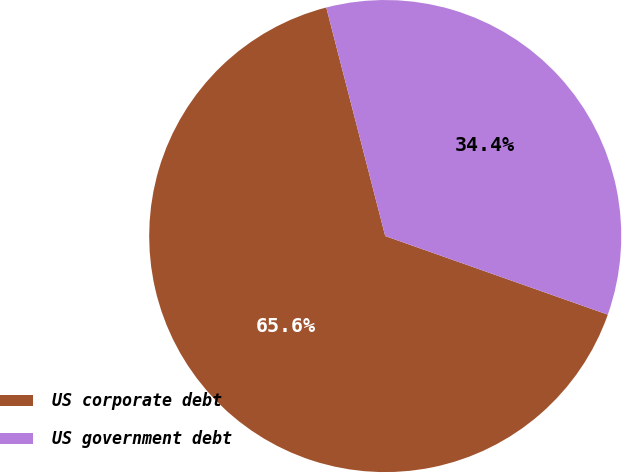Convert chart. <chart><loc_0><loc_0><loc_500><loc_500><pie_chart><fcel>US corporate debt<fcel>US government debt<nl><fcel>65.58%<fcel>34.42%<nl></chart> 